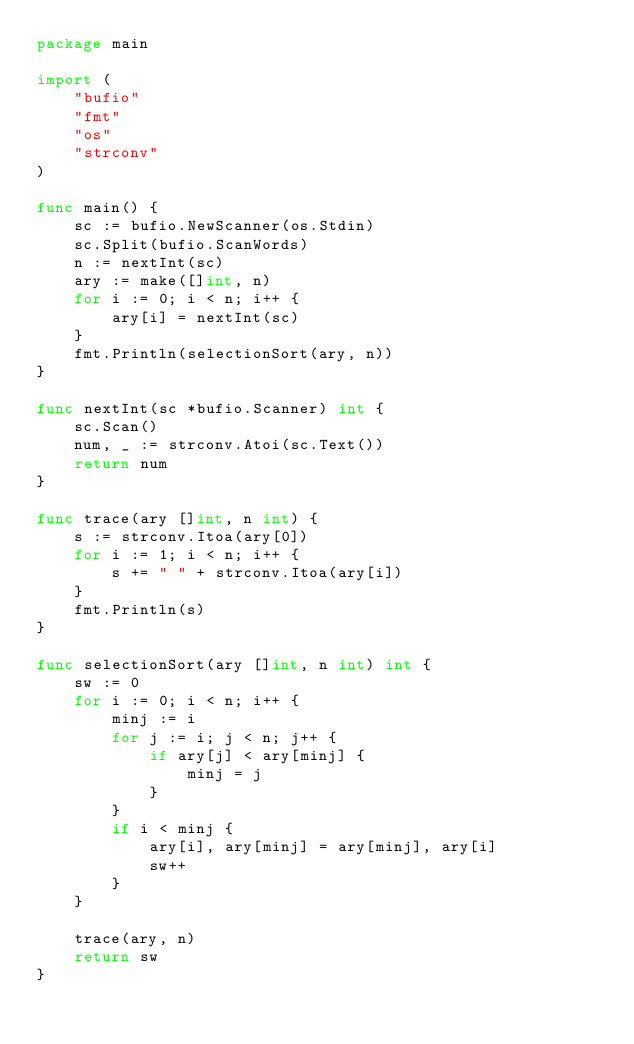Convert code to text. <code><loc_0><loc_0><loc_500><loc_500><_Go_>package main

import (
	"bufio"
	"fmt"
	"os"
	"strconv"
)

func main() {
	sc := bufio.NewScanner(os.Stdin)
	sc.Split(bufio.ScanWords)
	n := nextInt(sc)
	ary := make([]int, n)
	for i := 0; i < n; i++ {
		ary[i] = nextInt(sc)
	}
	fmt.Println(selectionSort(ary, n))
}

func nextInt(sc *bufio.Scanner) int {
	sc.Scan()
	num, _ := strconv.Atoi(sc.Text())
	return num
}

func trace(ary []int, n int) {
	s := strconv.Itoa(ary[0])
	for i := 1; i < n; i++ {
		s += " " + strconv.Itoa(ary[i])
	}
	fmt.Println(s)
}

func selectionSort(ary []int, n int) int {
	sw := 0
	for i := 0; i < n; i++ {
		minj := i
		for j := i; j < n; j++ {
			if ary[j] < ary[minj] {
				minj = j
			}
		}
		if i < minj {
			ary[i], ary[minj] = ary[minj], ary[i]
			sw++
		}
	}

	trace(ary, n)
	return sw
}

</code> 